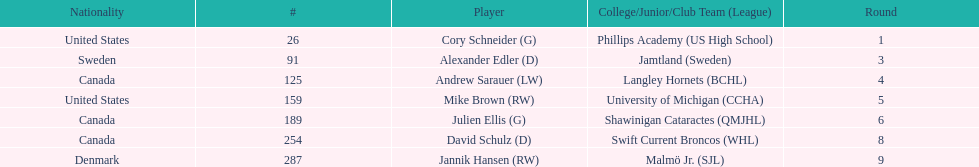How many canadian players are listed? 3. 